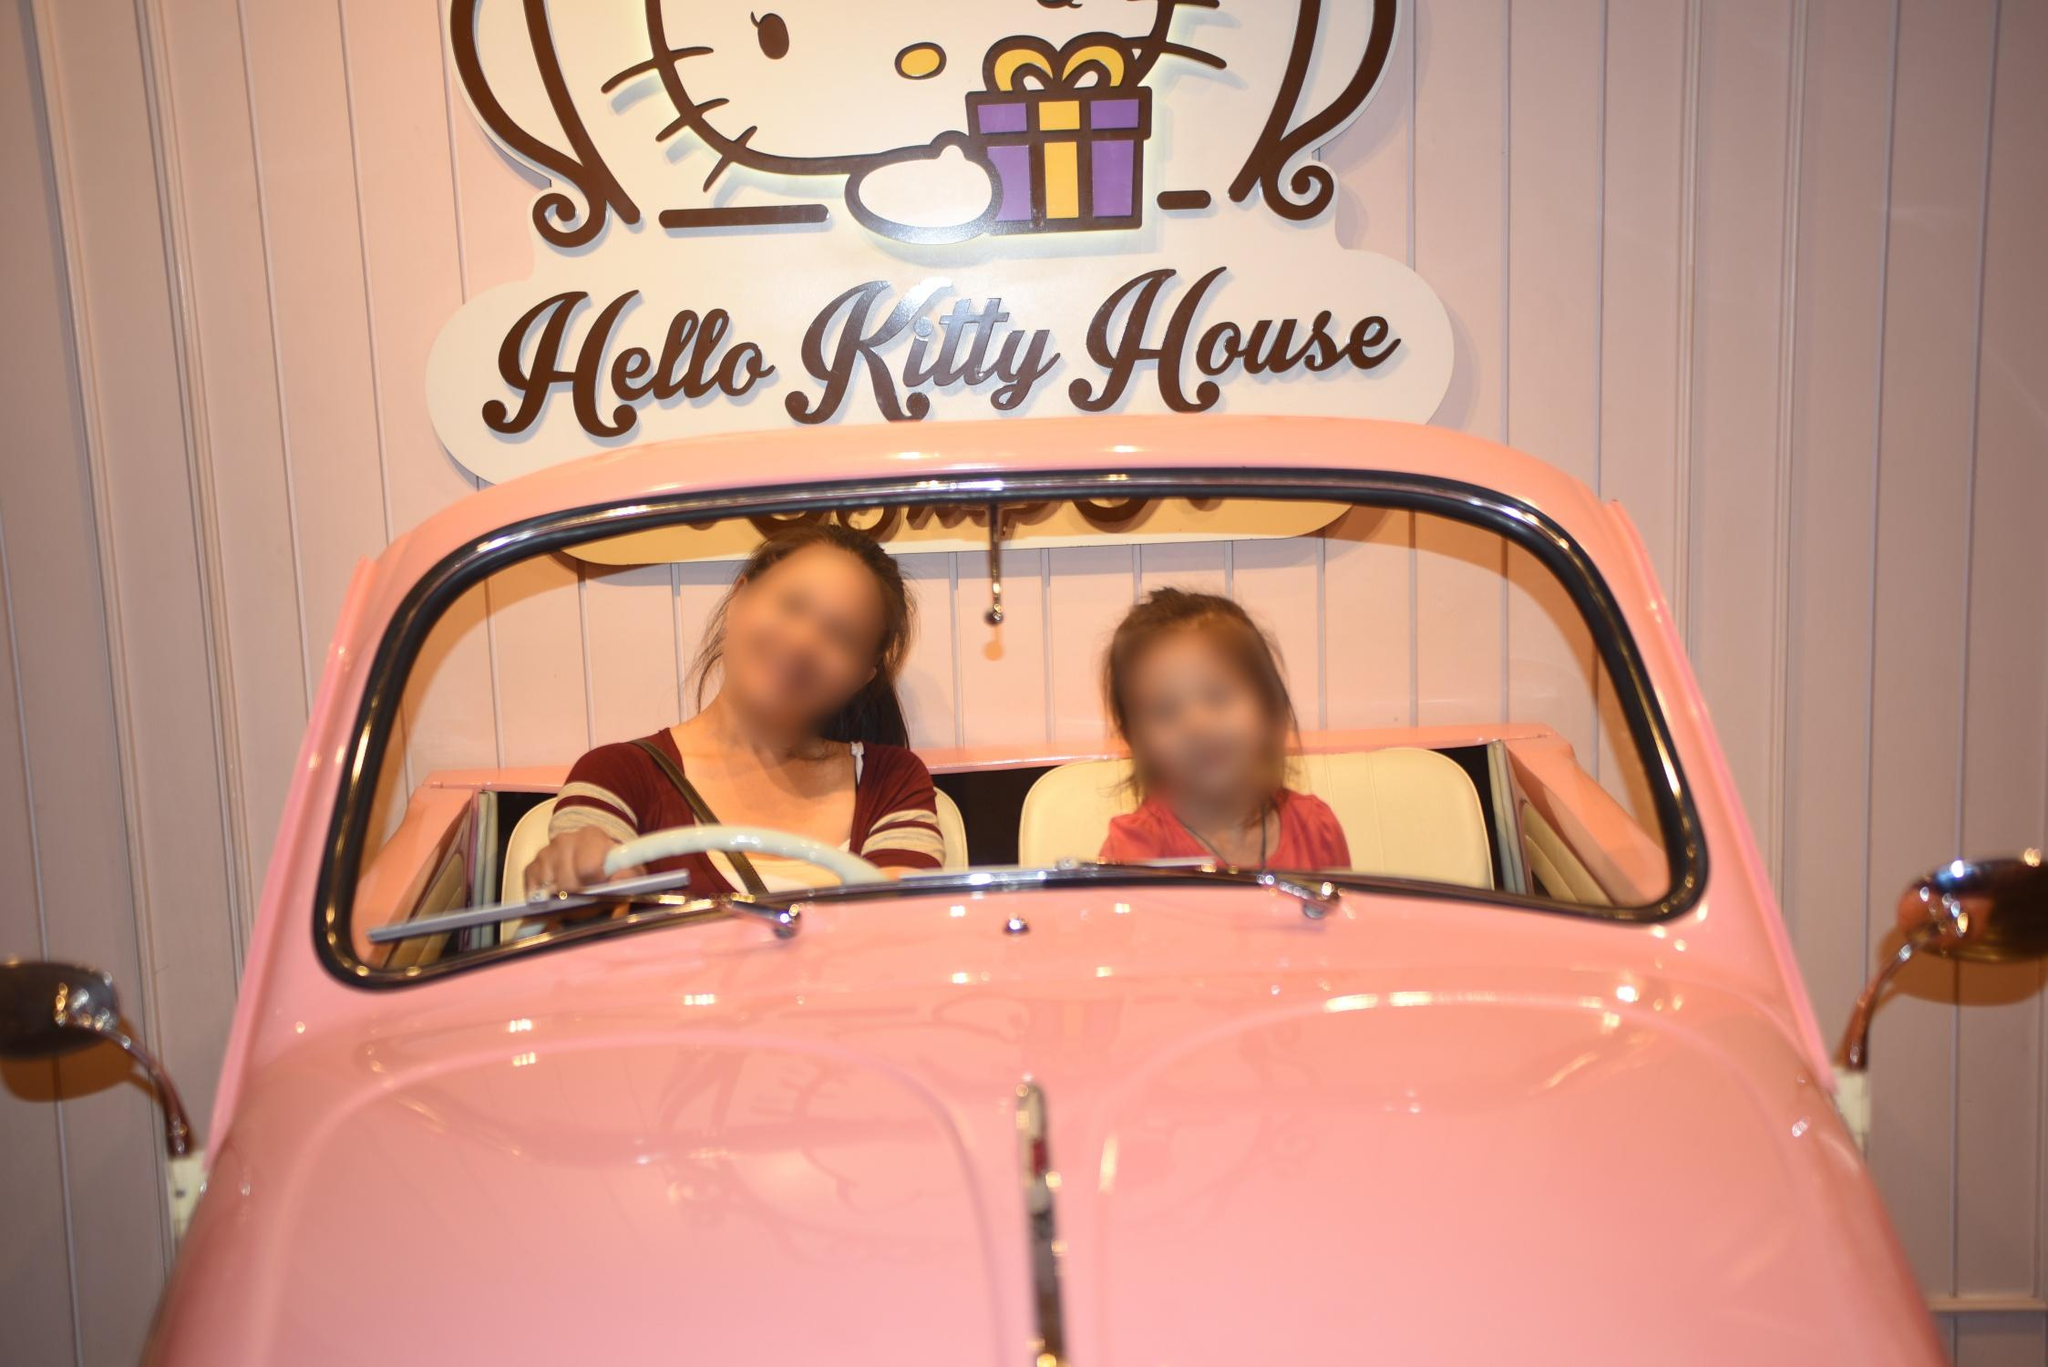Can you tell me more about the 'Hello Kitty House'? Certainly! The 'Hello Kitty House' is often a themed attraction, cafe, or shop dedicated to the popular character Hello Kitty. It typically features a variety of merchandise, food, and decor all centered around Hello Kitty and her friends, creating a playful and inviting environment for fans and visitors. 